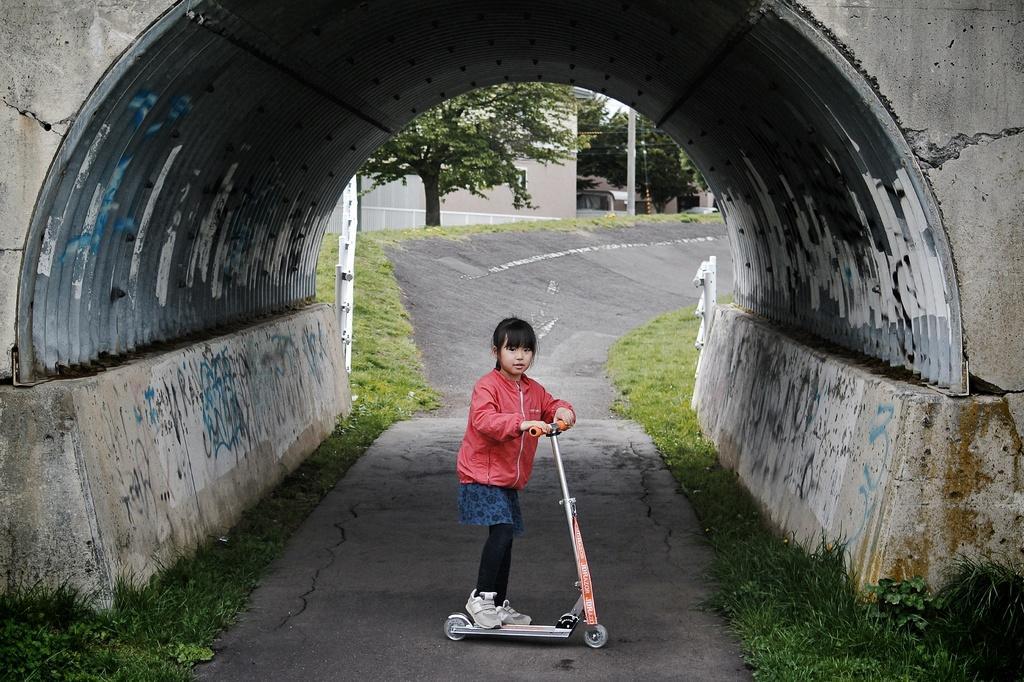Could you give a brief overview of what you see in this image? In this picture there is a girl who is wearing jacket, trouser and shoes. She is standing on this electric scooter. In the background I can see the building, plants, trees, grass and pole. 